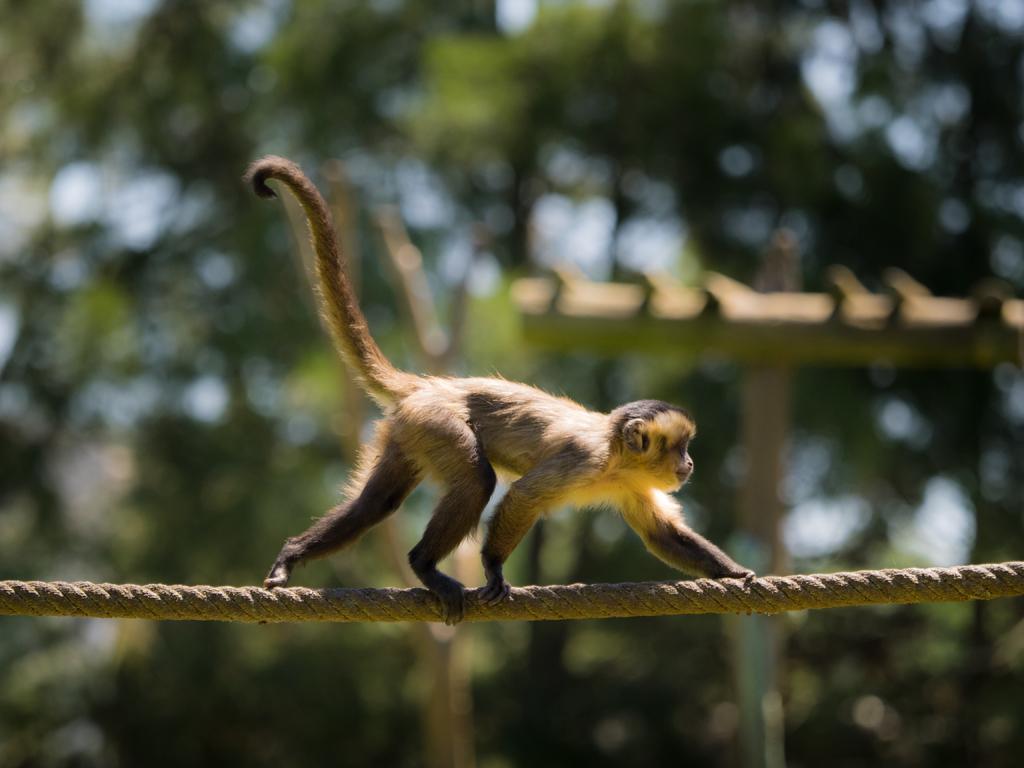Could you give a brief overview of what you see in this image? In the middle of the image there is a monkey walking on the rope towards the right side. In the background there are trees and some sticks. 